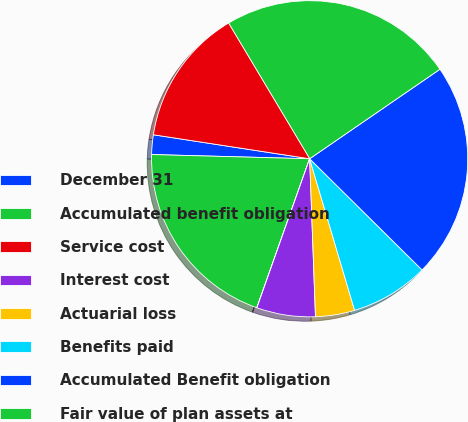<chart> <loc_0><loc_0><loc_500><loc_500><pie_chart><fcel>December 31<fcel>Accumulated benefit obligation<fcel>Service cost<fcel>Interest cost<fcel>Actuarial loss<fcel>Benefits paid<fcel>Accumulated Benefit obligation<fcel>Fair value of plan assets at<fcel>Actual return on plan assets<nl><fcel>2.0%<fcel>20.0%<fcel>0.01%<fcel>6.0%<fcel>4.0%<fcel>8.0%<fcel>21.99%<fcel>23.99%<fcel>14.0%<nl></chart> 